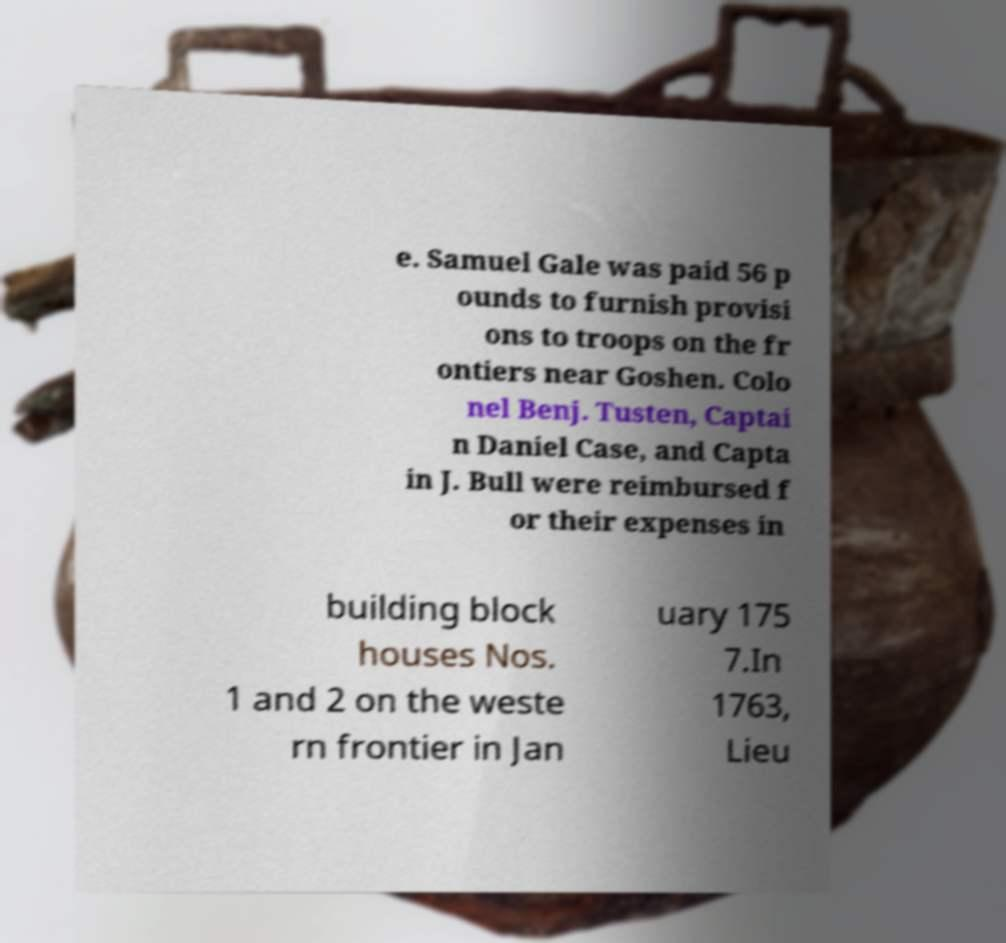Can you read and provide the text displayed in the image?This photo seems to have some interesting text. Can you extract and type it out for me? e. Samuel Gale was paid 56 p ounds to furnish provisi ons to troops on the fr ontiers near Goshen. Colo nel Benj. Tusten, Captai n Daniel Case, and Capta in J. Bull were reimbursed f or their expenses in building block houses Nos. 1 and 2 on the weste rn frontier in Jan uary 175 7.In 1763, Lieu 